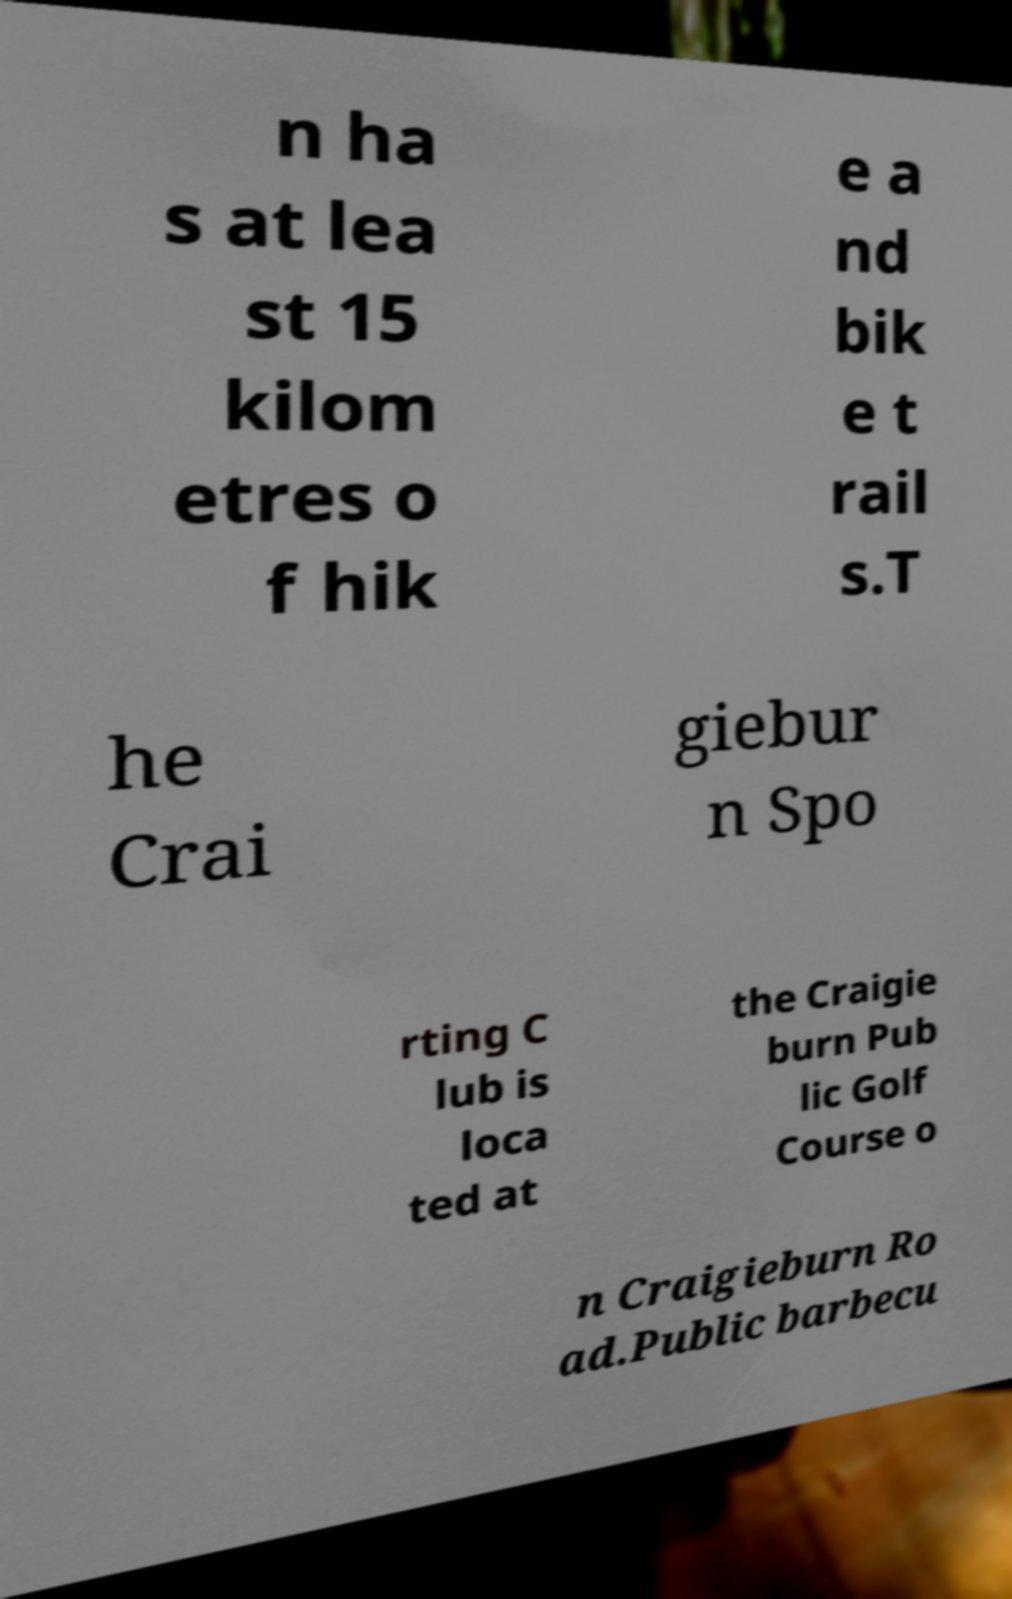For documentation purposes, I need the text within this image transcribed. Could you provide that? n ha s at lea st 15 kilom etres o f hik e a nd bik e t rail s.T he Crai giebur n Spo rting C lub is loca ted at the Craigie burn Pub lic Golf Course o n Craigieburn Ro ad.Public barbecu 